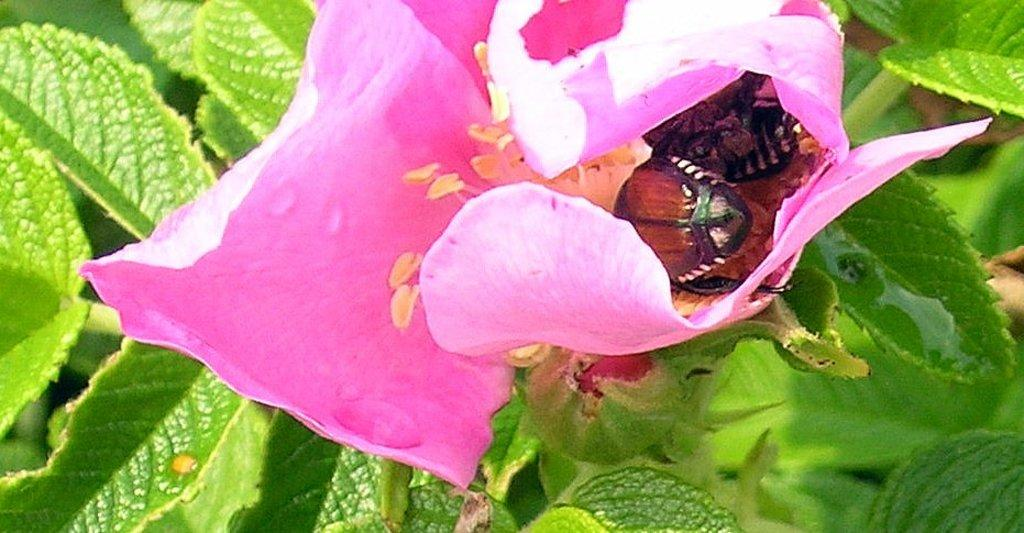What type of flower is in the image? There is a pink flower in the image. Are there any other living organisms interacting with the flower? Yes, insects are present on the pink flower. What can be seen in the background of the image? There are green leaves in the background of the image. How many chickens are sitting on the toothbrush in the image? There are no chickens or toothbrushes present in the image. 